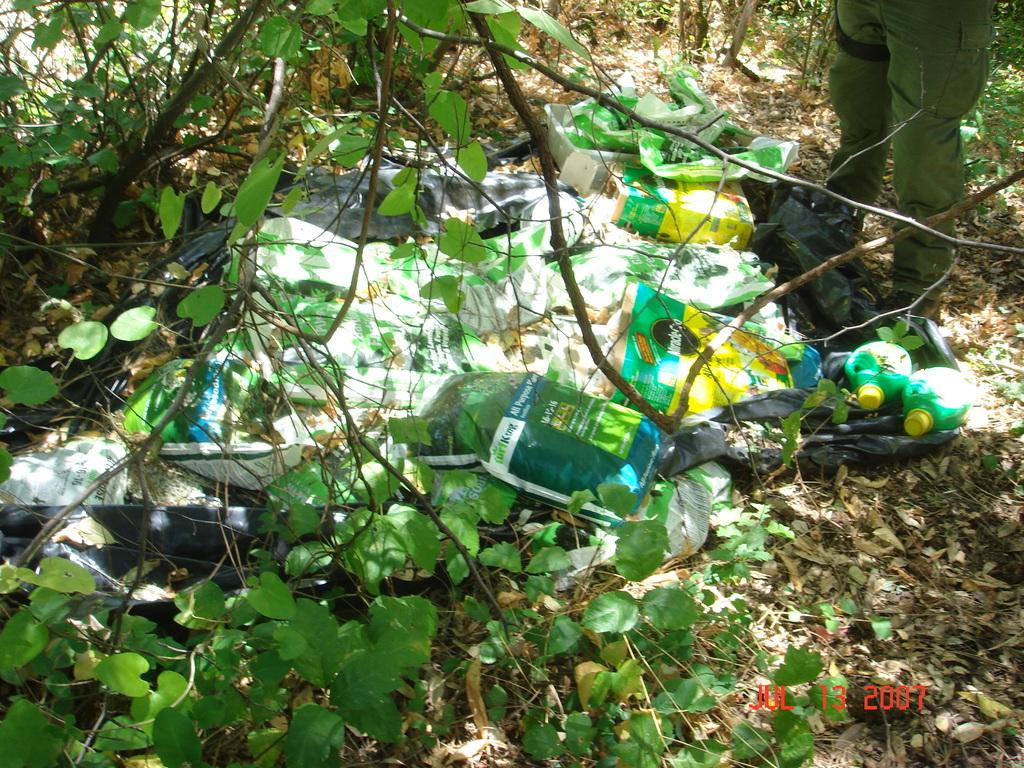What is the setting of the image? The image is taken inside a forest. What items can be seen in the image related to protection from the elements? There are plastic covers and water bottles in the image. What is the person in the image wearing? The guy in the image is wearing a green uniform. Where is the guy located in the image? The guy is on the right side of the image. What type of wrench is the guy using in the image? There is no wrench present in the image; the guy is wearing a green uniform and standing in a forest setting. What language is the guy speaking in the image? There is no indication of the guy speaking in the image, nor is there any information about the language he might be speaking. 